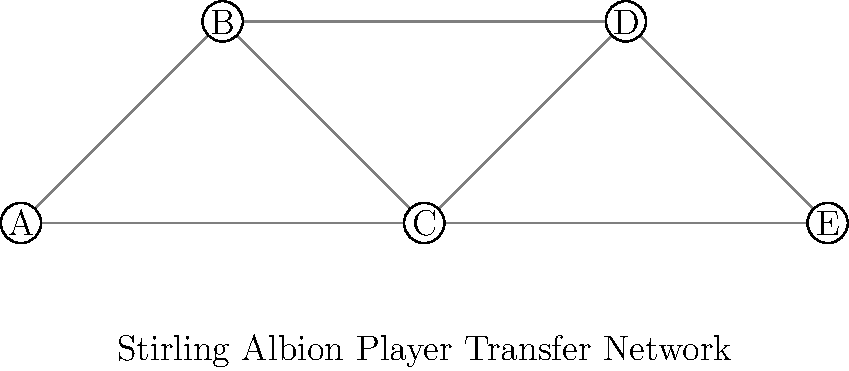In the graph representing Stirling Albion's player transfer network over the past 30 years, each node represents a club and each edge represents a player transfer between clubs. What is the minimum number of edges that need to be removed to disconnect node A (representing Stirling Albion) from node E? To solve this problem, we need to find the minimum cut between nodes A and E. Let's follow these steps:

1. Identify all possible paths from A to E:
   - A → B → D → E
   - A → C → D → E
   - A → C → E

2. Observe that all paths must go through either B or C to reach E.

3. Count the number of edges connecting A to B and C:
   - A to B: 1 edge
   - A to C: 1 edge

4. The minimum number of edges to remove is the smaller of these two counts.

5. In this case, removing either the edge between A and B or the edge between A and C will disconnect A from E.

Therefore, the minimum number of edges that need to be removed to disconnect A from E is 1.
Answer: 1 